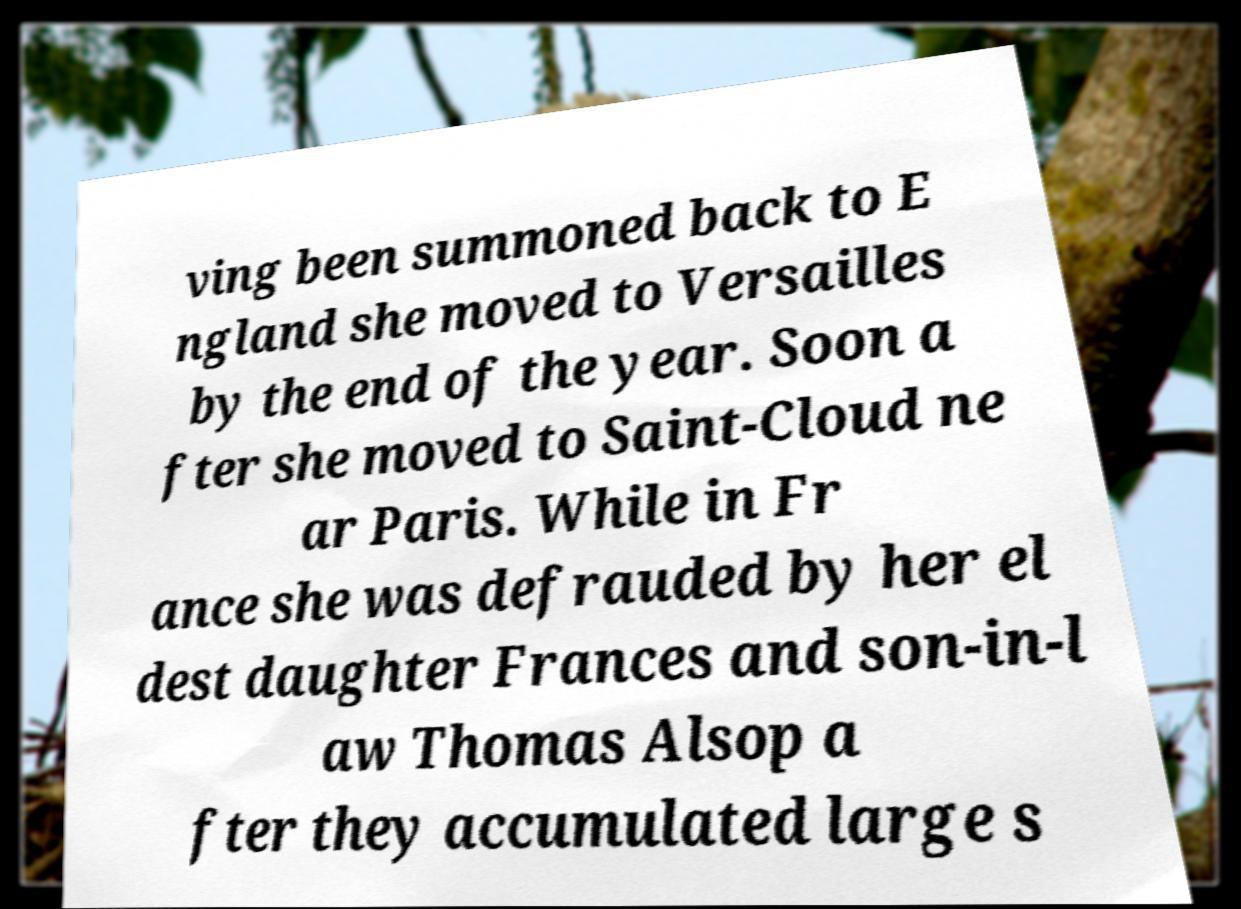Please identify and transcribe the text found in this image. ving been summoned back to E ngland she moved to Versailles by the end of the year. Soon a fter she moved to Saint-Cloud ne ar Paris. While in Fr ance she was defrauded by her el dest daughter Frances and son-in-l aw Thomas Alsop a fter they accumulated large s 